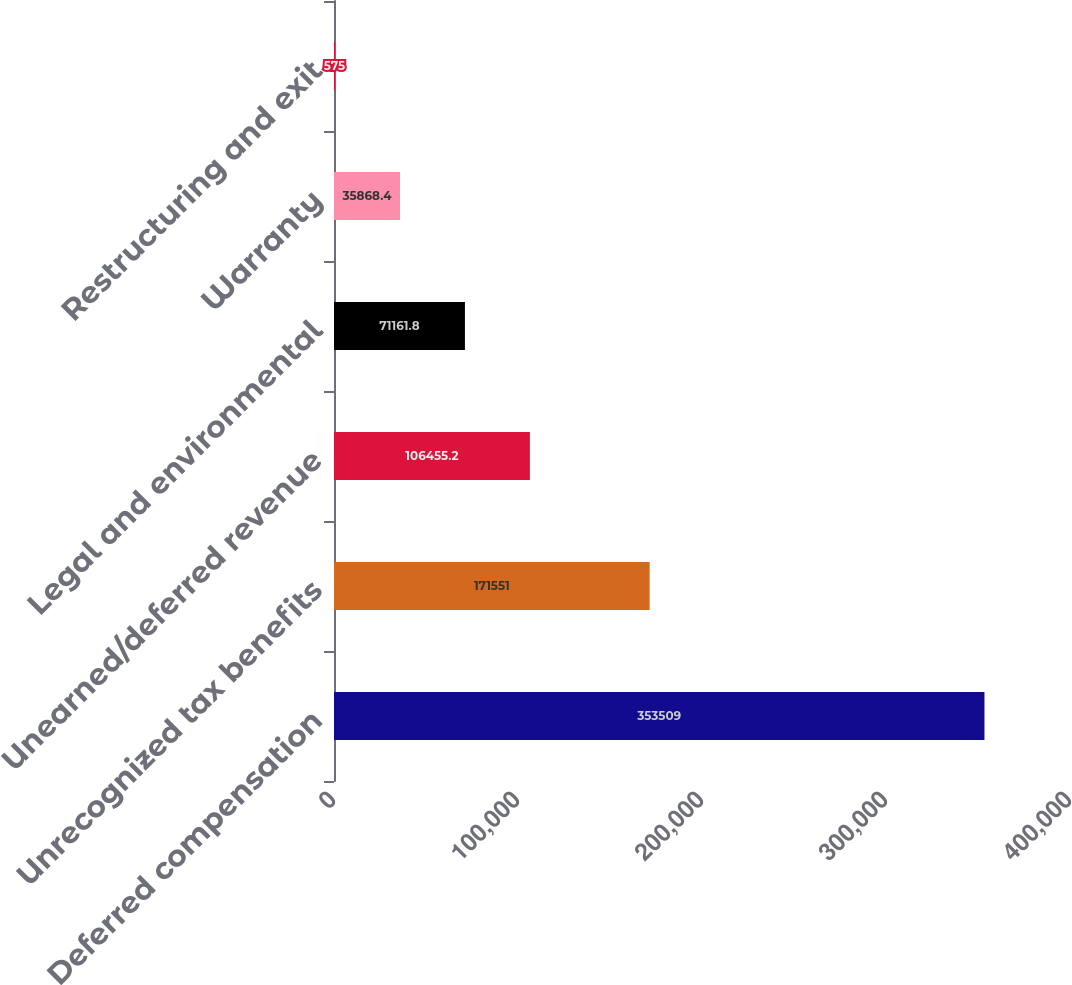<chart> <loc_0><loc_0><loc_500><loc_500><bar_chart><fcel>Deferred compensation<fcel>Unrecognized tax benefits<fcel>Unearned/deferred revenue<fcel>Legal and environmental<fcel>Warranty<fcel>Restructuring and exit<nl><fcel>353509<fcel>171551<fcel>106455<fcel>71161.8<fcel>35868.4<fcel>575<nl></chart> 